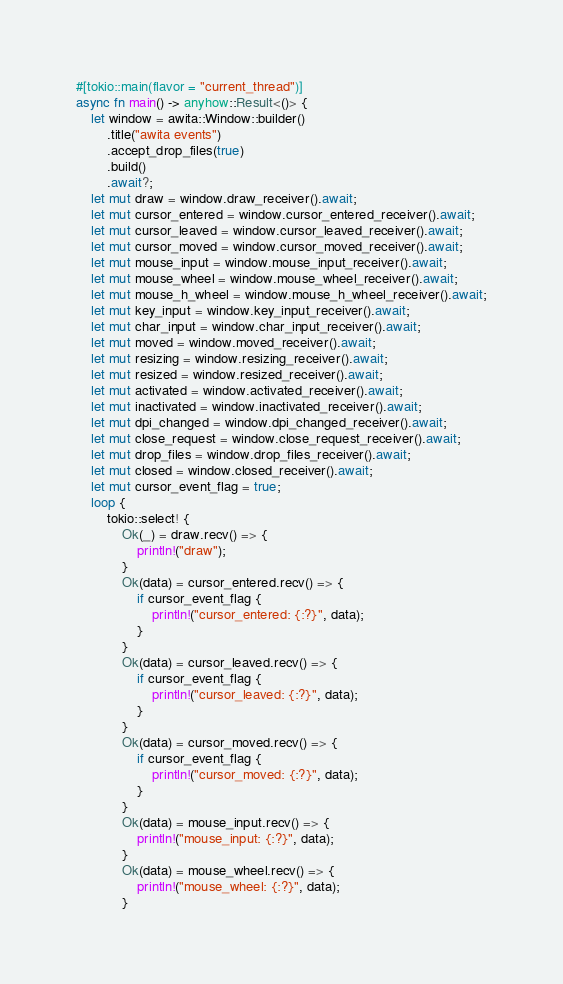Convert code to text. <code><loc_0><loc_0><loc_500><loc_500><_Rust_>#[tokio::main(flavor = "current_thread")]
async fn main() -> anyhow::Result<()> {
    let window = awita::Window::builder()
        .title("awita events")
        .accept_drop_files(true)
        .build()
        .await?;
    let mut draw = window.draw_receiver().await;
    let mut cursor_entered = window.cursor_entered_receiver().await;
    let mut cursor_leaved = window.cursor_leaved_receiver().await;
    let mut cursor_moved = window.cursor_moved_receiver().await;
    let mut mouse_input = window.mouse_input_receiver().await;
    let mut mouse_wheel = window.mouse_wheel_receiver().await;
    let mut mouse_h_wheel = window.mouse_h_wheel_receiver().await;
    let mut key_input = window.key_input_receiver().await;
    let mut char_input = window.char_input_receiver().await;
    let mut moved = window.moved_receiver().await;
    let mut resizing = window.resizing_receiver().await;
    let mut resized = window.resized_receiver().await;
    let mut activated = window.activated_receiver().await;
    let mut inactivated = window.inactivated_receiver().await;
    let mut dpi_changed = window.dpi_changed_receiver().await;
    let mut close_request = window.close_request_receiver().await;
    let mut drop_files = window.drop_files_receiver().await;
    let mut closed = window.closed_receiver().await;
    let mut cursor_event_flag = true;
    loop {
        tokio::select! {
            Ok(_) = draw.recv() => {
                println!("draw");
            }
            Ok(data) = cursor_entered.recv() => {
                if cursor_event_flag {
                    println!("cursor_entered: {:?}", data);
                }
            }
            Ok(data) = cursor_leaved.recv() => {
                if cursor_event_flag {
                    println!("cursor_leaved: {:?}", data);
                }
            }
            Ok(data) = cursor_moved.recv() => {
                if cursor_event_flag {
                    println!("cursor_moved: {:?}", data);
                }
            }
            Ok(data) = mouse_input.recv() => {
                println!("mouse_input: {:?}", data);
            }
            Ok(data) = mouse_wheel.recv() => {
                println!("mouse_wheel: {:?}", data);
            }</code> 